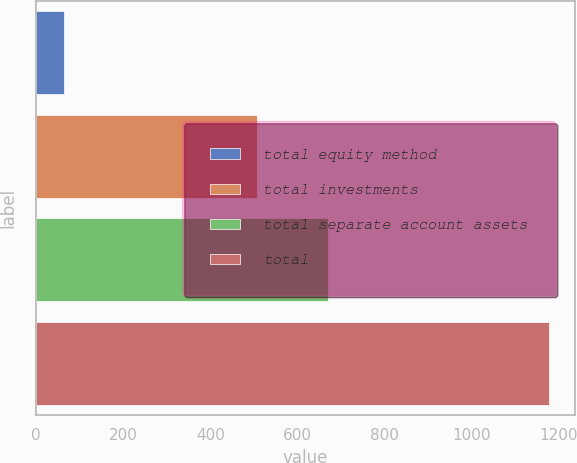<chart> <loc_0><loc_0><loc_500><loc_500><bar_chart><fcel>total equity method<fcel>total investments<fcel>total separate account assets<fcel>total<nl><fcel>64<fcel>508<fcel>670<fcel>1178<nl></chart> 